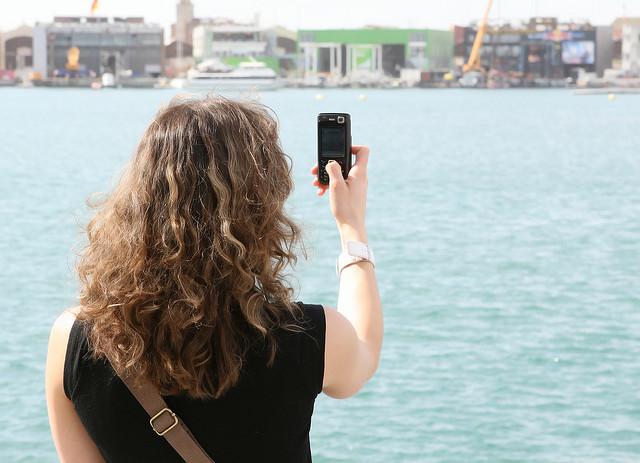Is this woman taking a picture on a phone or camera?
Keep it brief. Phone. Is the woman wearing a bracelet?
Keep it brief. Yes. What is she doing?
Give a very brief answer. Taking picture. 